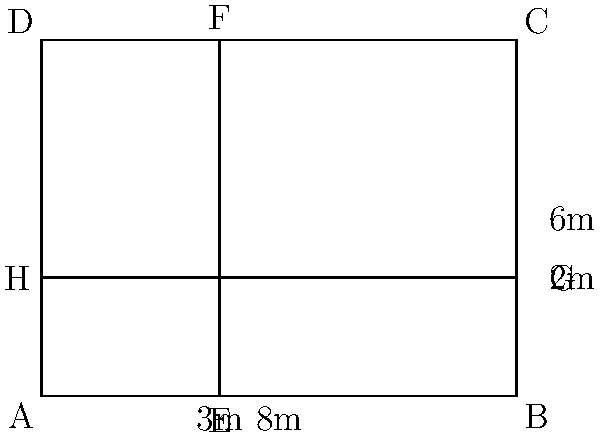A hospital is designing a new ward layout. The room is rectangular, measuring 8m by 6m. The room needs to be divided into three sections: a patient area, a visitor area, and a staff area. The patient area is a rectangle on the left side of the room, measuring 3m wide. The staff area is a rectangle at the top of the room, measuring 2m high. The remaining space is the visitor area.

Calculate the area of the visitor section in square meters. Let's approach this step-by-step:

1) First, let's calculate the total area of the room:
   Total area = length × width = 8m × 6m = 48m²

2) Now, let's calculate the area of the patient section:
   Patient area = length × width = 3m × 6m = 18m²

3) Next, let's calculate the area of the staff section:
   Staff area = length × width = 8m × 2m = 16m²

4) The visitor area is the remaining space. We can calculate this by subtracting the patient and staff areas from the total area:
   Visitor area = Total area - (Patient area + Staff area)
                = 48m² - (18m² + 16m²)
                = 48m² - 34m²
                = 14m²

Therefore, the area of the visitor section is 14 square meters.
Answer: 14m² 